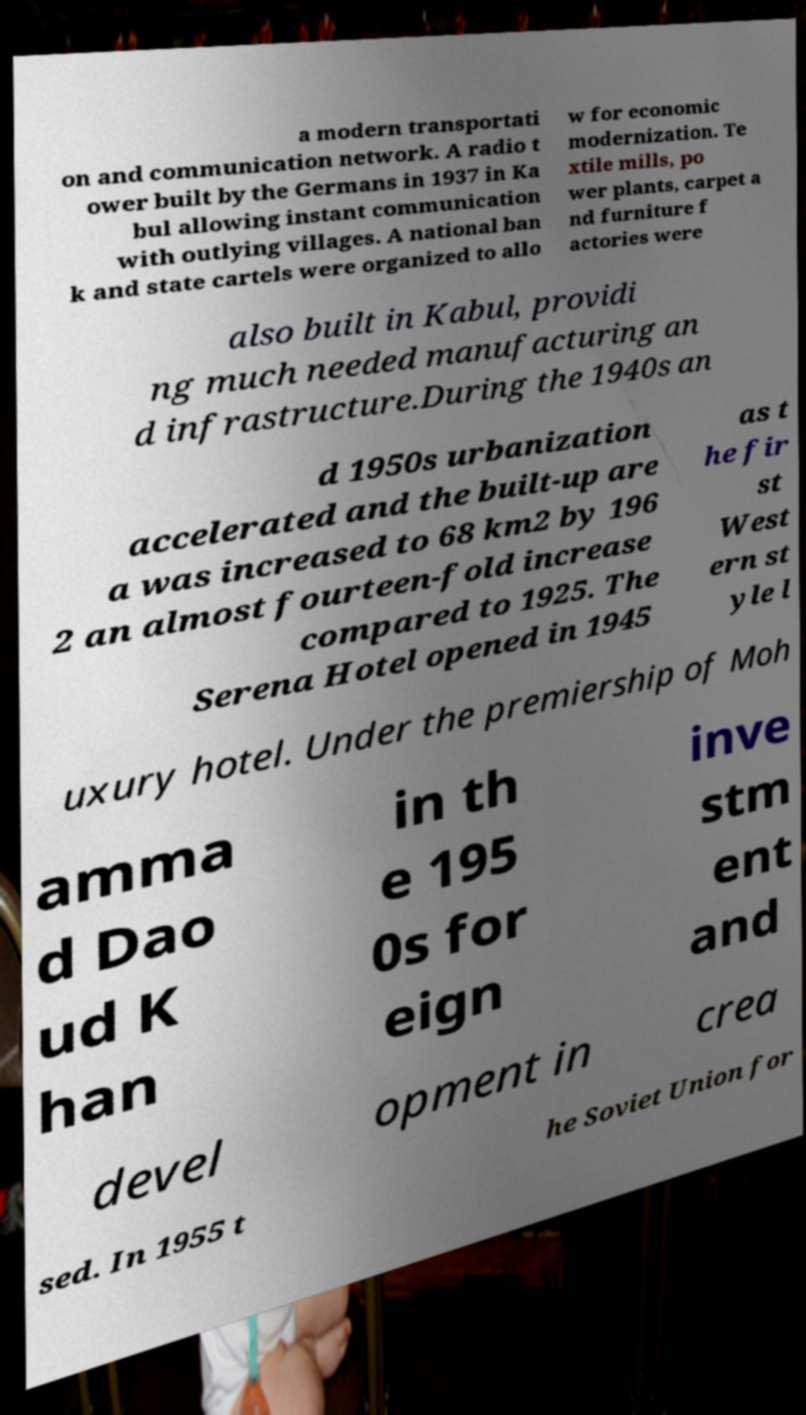I need the written content from this picture converted into text. Can you do that? a modern transportati on and communication network. A radio t ower built by the Germans in 1937 in Ka bul allowing instant communication with outlying villages. A national ban k and state cartels were organized to allo w for economic modernization. Te xtile mills, po wer plants, carpet a nd furniture f actories were also built in Kabul, providi ng much needed manufacturing an d infrastructure.During the 1940s an d 1950s urbanization accelerated and the built-up are a was increased to 68 km2 by 196 2 an almost fourteen-fold increase compared to 1925. The Serena Hotel opened in 1945 as t he fir st West ern st yle l uxury hotel. Under the premiership of Moh amma d Dao ud K han in th e 195 0s for eign inve stm ent and devel opment in crea sed. In 1955 t he Soviet Union for 